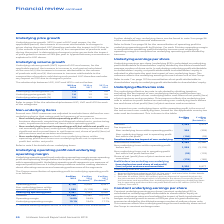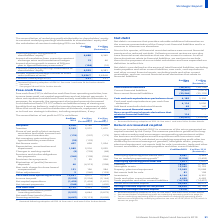According to Unilever Plc's financial document, How is the constant underlying earnings per share calculated? underlying profit attributable to shareholders’ equity at constant exchange rates and excluding the impact of both translational hedges and price growth in excess of 26% per year in hyperinflationary economies divided by the diluted average number of ordinary share units. The document states: "share (constant underlying EPS) is calculated as underlying profit attributable to shareholders’ equity at constant exchange rates and excluding the i..." Also, What does the constant underlying earnings per share reflect? underlying earnings for each ordinary share unit of the Group in constant exchange rates. The document states: "f ordinary share units. This measure reflects the underlying earnings for each ordinary share unit of the Group in constant exchange rates...." Also, What is the EPS in 2019? According to the financial document, 2.51 (in millions). The relevant text states: "Constant underlying EPS (€) 2.51 2.37..." Also, can you calculate: What is the percentage increase Underlying profit attributable to shareholders’ equity from 2018 to 2019? To answer this question, I need to perform calculations using the financial data. The calculation is: 6,688 / 6,345 - 1, which equals 5.41 (percentage). This is based on the information: "it attributable to shareholders’ equity (b) 6,688 6,345 g profit attributable to shareholders’ equity (b) 6,688 6,345..." The key data points involved are: 6,345, 6,688. Also, can you calculate: What is the change in the Diluted combined average number of share units (millions of units) from 2018 to 2019? Based on the calculation: 2,626.7 - 2,694.8, the result is -68.1 (in millions). This is based on the information: "average number of share units (millions of units) 2,626.7 2,694.8 number of share units (millions of units) 2,626.7 2,694.8..." The key data points involved are: 2,626.7, 2,694.8. Also, can you calculate: What is the average Constant underlying earnings attributable to shareholders’ equity? To answer this question, I need to perform calculations using the financial data. The calculation is: (6,593 + 6,381) / 2, which equals 6487 (in millions). This is based on the information: "ing earnings attributable to shareholders’ equity 6,593 6,381 rnings attributable to shareholders’ equity 6,593 6,381..." The key data points involved are: 6,381, 6,593. 